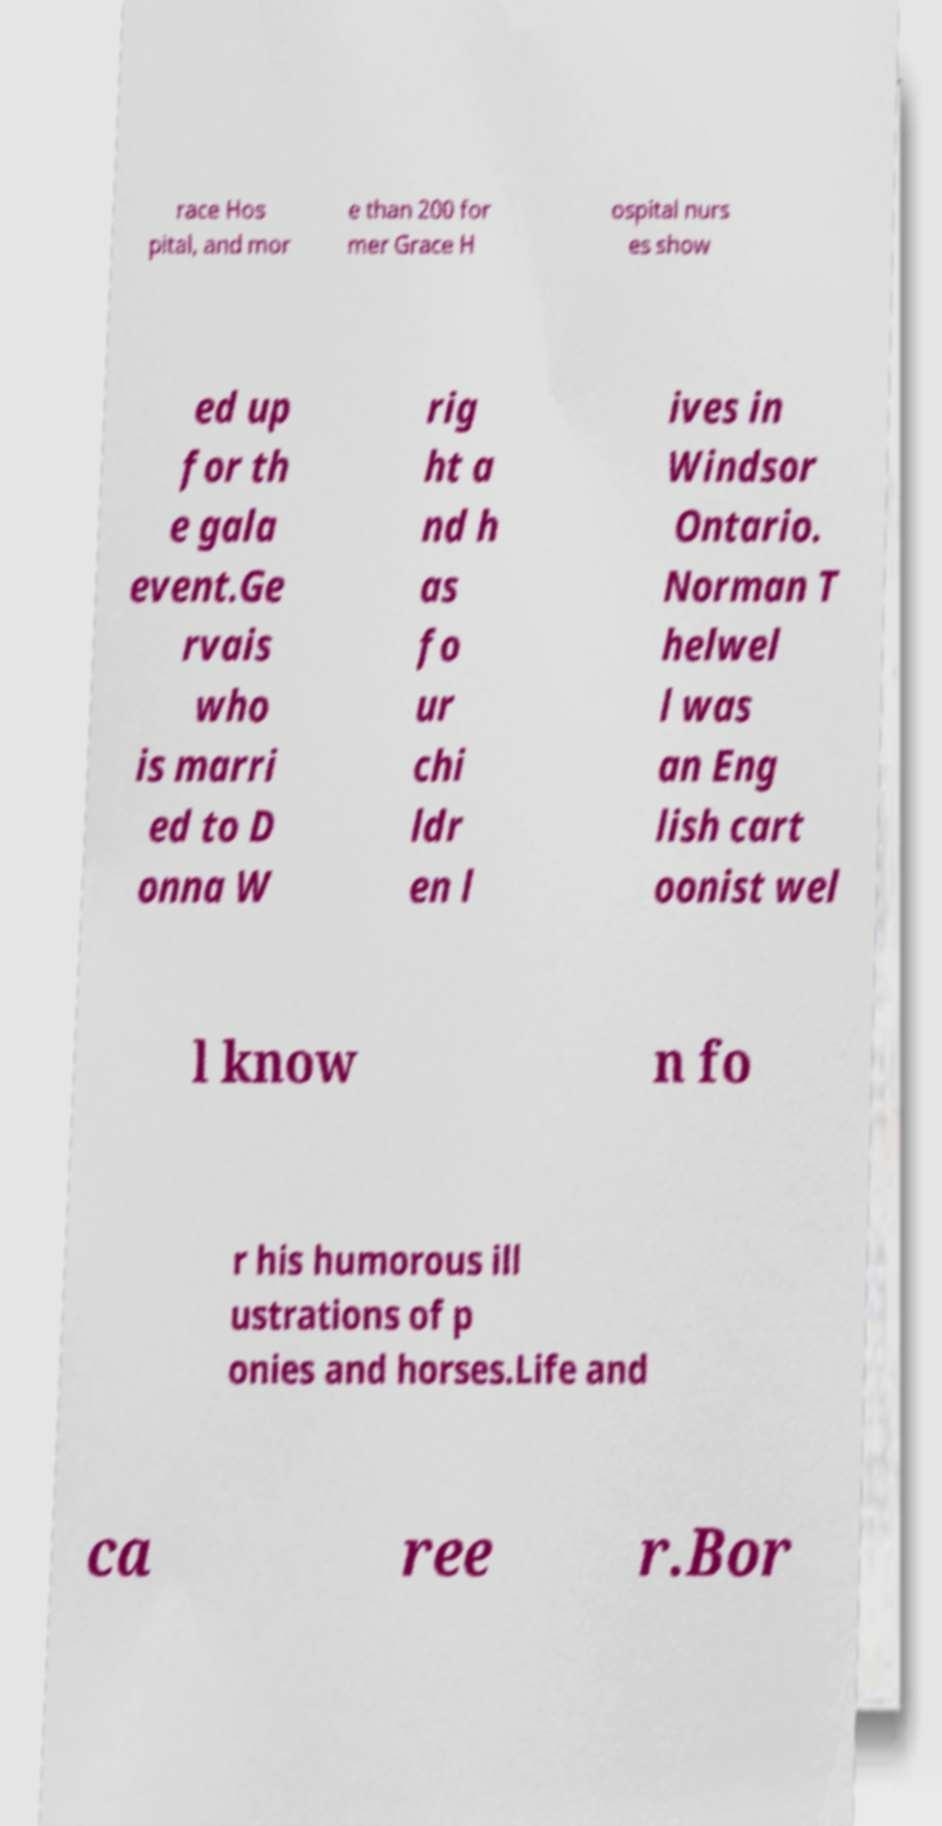What messages or text are displayed in this image? I need them in a readable, typed format. race Hos pital, and mor e than 200 for mer Grace H ospital nurs es show ed up for th e gala event.Ge rvais who is marri ed to D onna W rig ht a nd h as fo ur chi ldr en l ives in Windsor Ontario. Norman T helwel l was an Eng lish cart oonist wel l know n fo r his humorous ill ustrations of p onies and horses.Life and ca ree r.Bor 